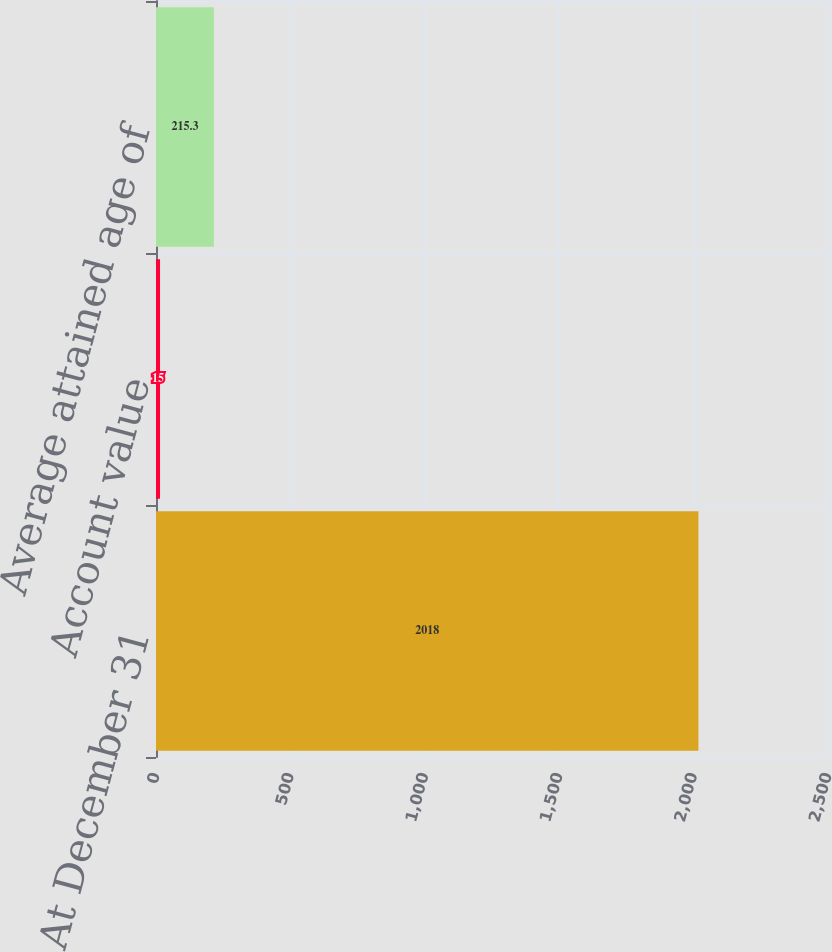Convert chart. <chart><loc_0><loc_0><loc_500><loc_500><bar_chart><fcel>At December 31<fcel>Account value<fcel>Average attained age of<nl><fcel>2018<fcel>15<fcel>215.3<nl></chart> 